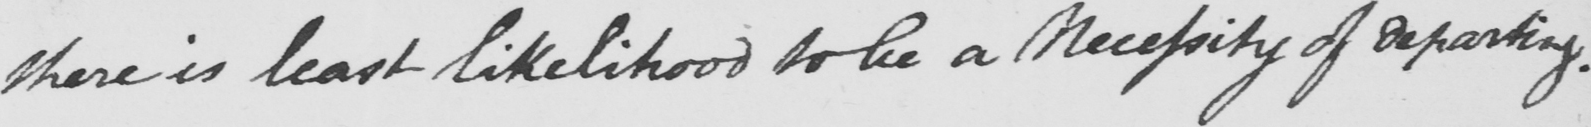Transcribe the text shown in this historical manuscript line. there is least likelihood to be a Necessity of disparity . 